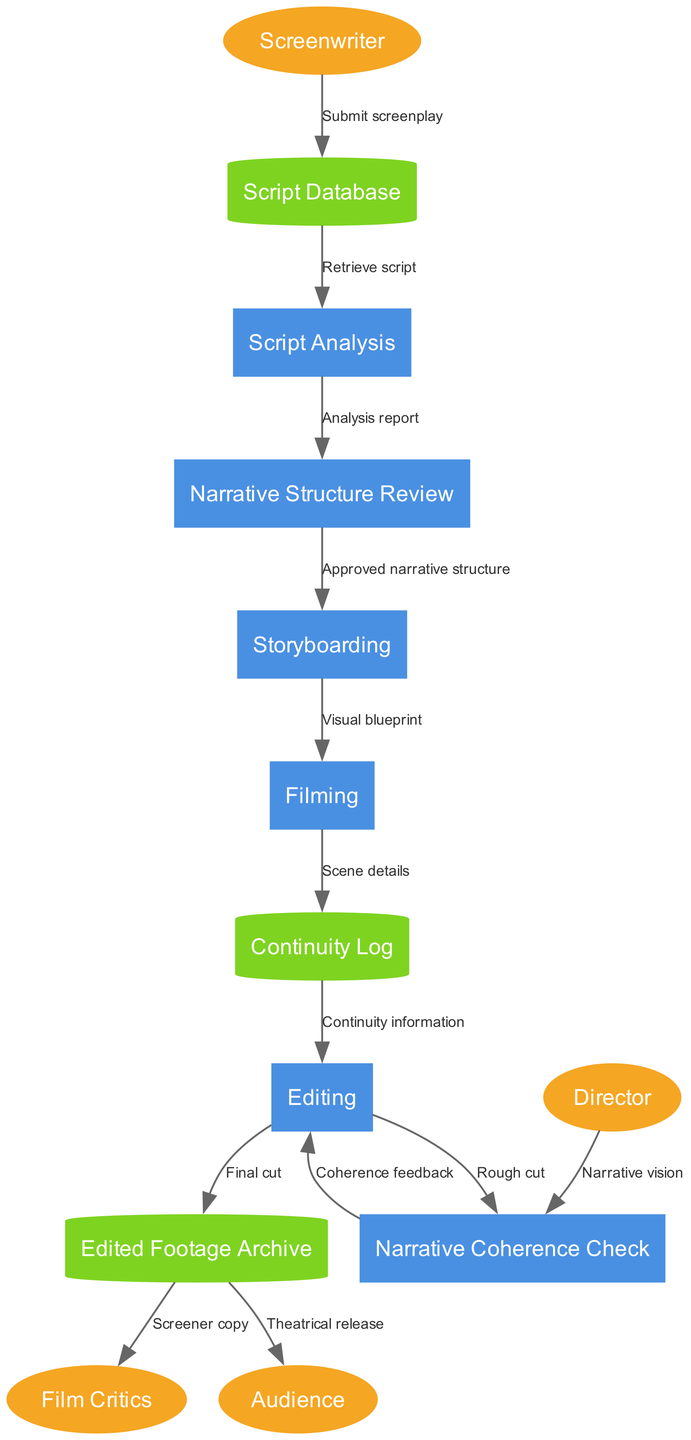What is the first process in the workflow? The workflow begins with the "Script Analysis" process, which is the first step taken after the screenplay is submitted to the Script Database.
Answer: Script Analysis How many external entities are represented in the diagram? There are four external entities identified in the diagram: Screenwriter, Director, Film Critics, and Audience. Therefore, the count is four.
Answer: Four What data flow comes from the Script Database to the Script Analysis? The data flow from the Script Database to the Script Analysis is labeled "Retrieve script," which indicates the action taken to access the script for analysis.
Answer: Retrieve script Which process receives feedback during the workflow? The "Editing" process receives feedback from the "Narrative Coherence Check" in the form of "Coherence feedback," which helps improve the narrative's cohesiveness.
Answer: Editing What is the final outcome of the Edited Footage Archive? The final outcome from the Edited Footage Archive leads to two actions: it sends a "Screener copy" to Film Critics and enables "Theatrical release" to the Audience, signifying its dual purpose after editing.
Answer: Screener copy and Theatrical release What process follows the Storyboarding in the workflow? After the Storyboarding process, the workflow proceeds to the "Filming" process, which is where the planned visuals are captured according to the storyboard.
Answer: Filming Which external entity interacts directly with the Narrative Coherence Check? The "Director" interacts directly with the "Narrative Coherence Check," providing their narrative vision to ensure the story's cohesiveness aligns with their intention.
Answer: Director How many processes are involved in ensuring narrative coherence? There are two processes involved in ensuring narrative coherence: "Narrative Coherence Check" and "Editing," which work together to achieve a cohesive narrative.
Answer: Two 